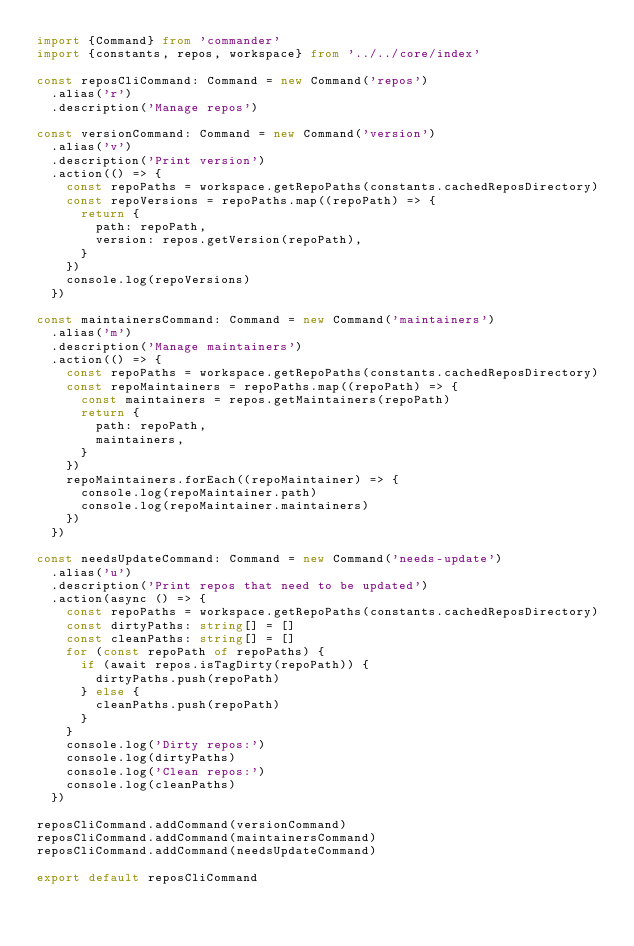<code> <loc_0><loc_0><loc_500><loc_500><_TypeScript_>import {Command} from 'commander'
import {constants, repos, workspace} from '../../core/index'

const reposCliCommand: Command = new Command('repos')
  .alias('r')
  .description('Manage repos')

const versionCommand: Command = new Command('version')
  .alias('v')
  .description('Print version')
  .action(() => {
    const repoPaths = workspace.getRepoPaths(constants.cachedReposDirectory)
    const repoVersions = repoPaths.map((repoPath) => {
      return {
        path: repoPath,
        version: repos.getVersion(repoPath),
      }
    })
    console.log(repoVersions)
  })

const maintainersCommand: Command = new Command('maintainers')
  .alias('m')
  .description('Manage maintainers')
  .action(() => {
    const repoPaths = workspace.getRepoPaths(constants.cachedReposDirectory)
    const repoMaintainers = repoPaths.map((repoPath) => {
      const maintainers = repos.getMaintainers(repoPath)
      return {
        path: repoPath,
        maintainers,
      }
    })
    repoMaintainers.forEach((repoMaintainer) => {
      console.log(repoMaintainer.path)
      console.log(repoMaintainer.maintainers)
    })
  })

const needsUpdateCommand: Command = new Command('needs-update')
  .alias('u')
  .description('Print repos that need to be updated')
  .action(async () => {
    const repoPaths = workspace.getRepoPaths(constants.cachedReposDirectory)
    const dirtyPaths: string[] = []
    const cleanPaths: string[] = []
    for (const repoPath of repoPaths) {
      if (await repos.isTagDirty(repoPath)) {
        dirtyPaths.push(repoPath)
      } else {
        cleanPaths.push(repoPath)
      }
    }
    console.log('Dirty repos:')
    console.log(dirtyPaths)
    console.log('Clean repos:')
    console.log(cleanPaths)
  })

reposCliCommand.addCommand(versionCommand)
reposCliCommand.addCommand(maintainersCommand)
reposCliCommand.addCommand(needsUpdateCommand)

export default reposCliCommand
</code> 